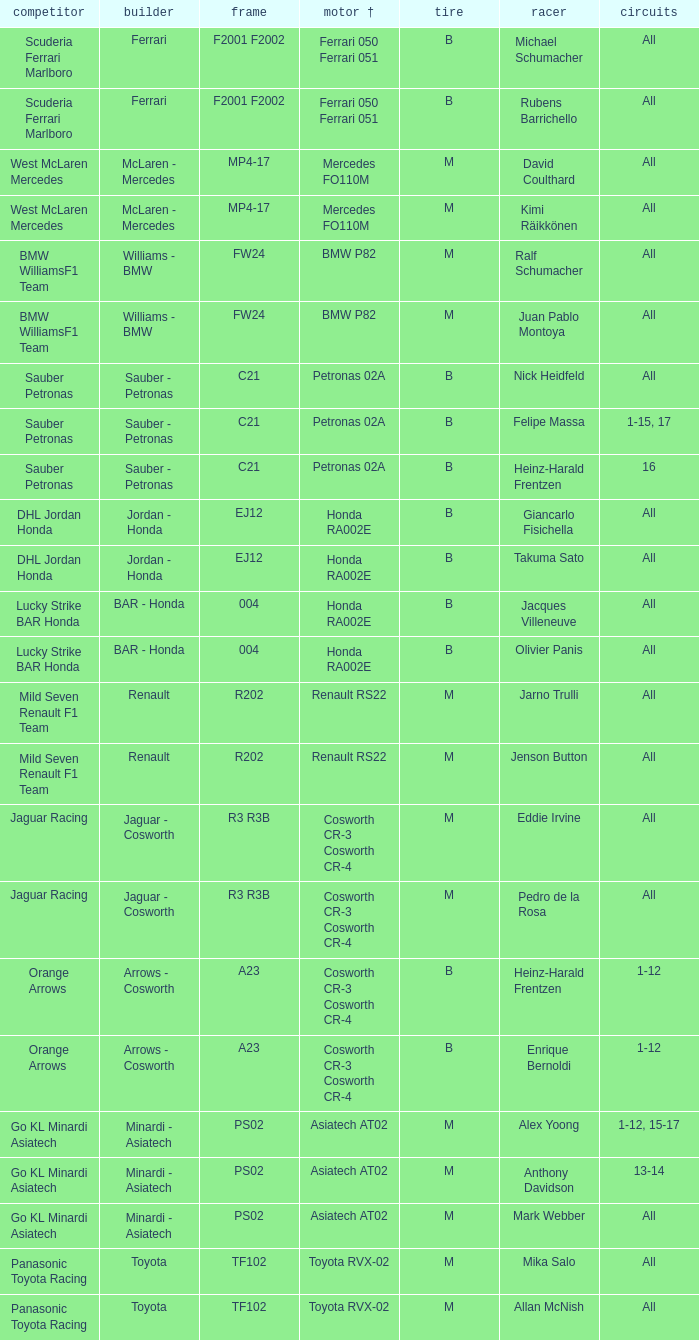When all rounds are finished, david coulthard is driving, and the tire is m, which engine is being used? Mercedes FO110M. 